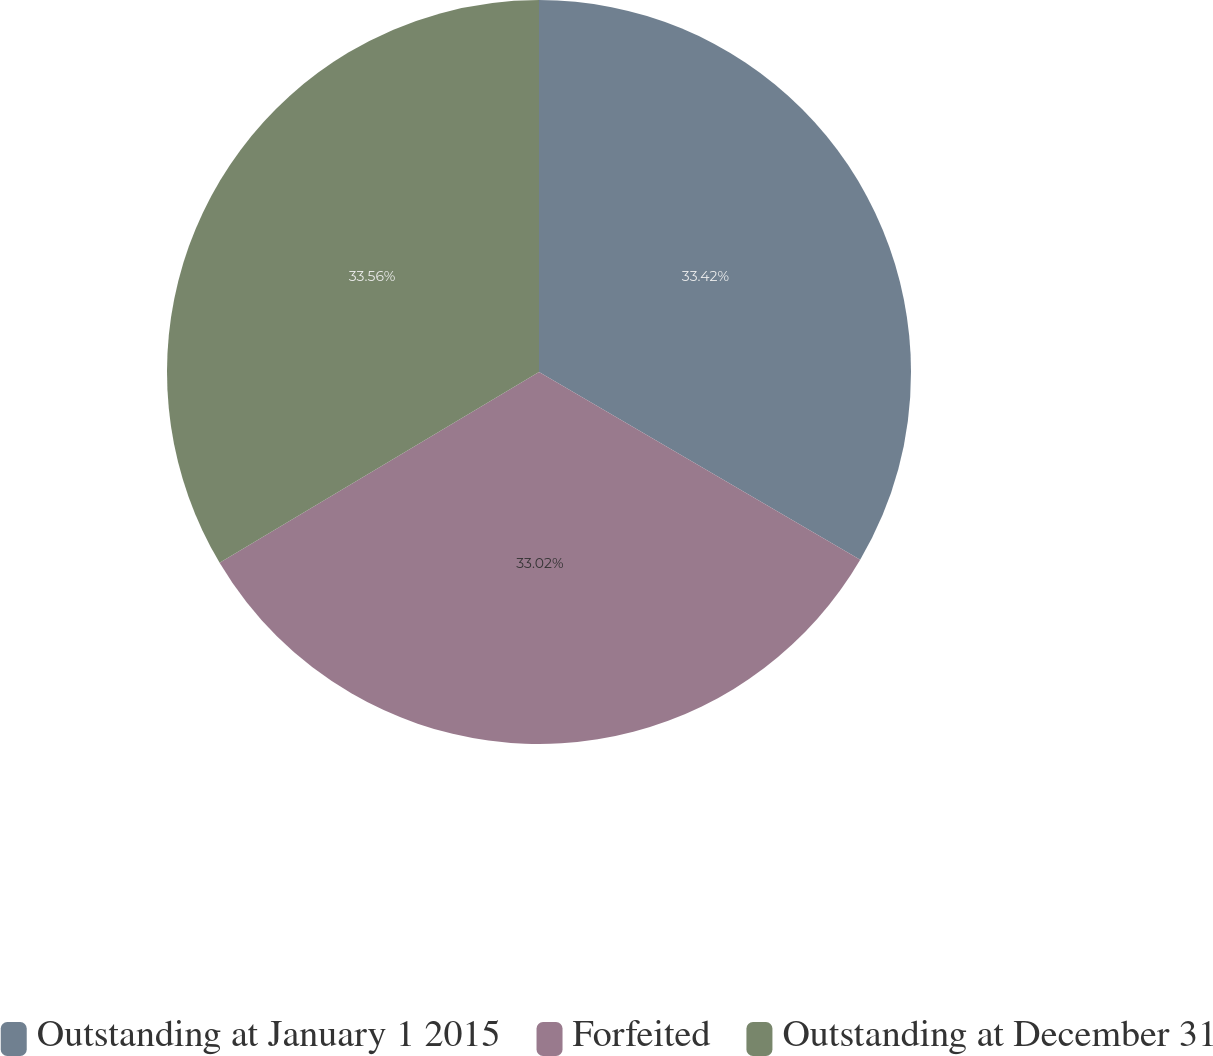Convert chart to OTSL. <chart><loc_0><loc_0><loc_500><loc_500><pie_chart><fcel>Outstanding at January 1 2015<fcel>Forfeited<fcel>Outstanding at December 31<nl><fcel>33.42%<fcel>33.02%<fcel>33.57%<nl></chart> 